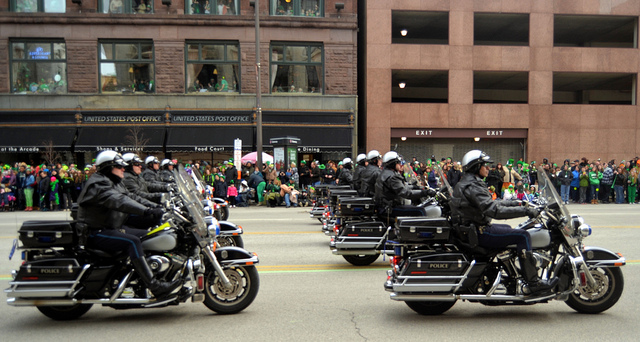Read all the text in this image. EXIT 